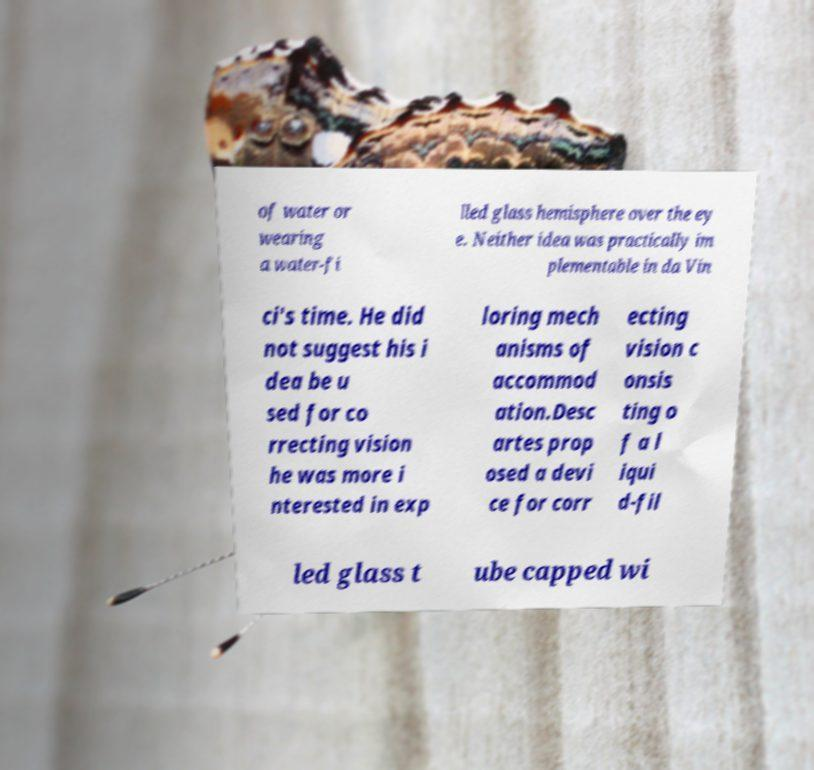Can you read and provide the text displayed in the image?This photo seems to have some interesting text. Can you extract and type it out for me? of water or wearing a water-fi lled glass hemisphere over the ey e. Neither idea was practically im plementable in da Vin ci's time. He did not suggest his i dea be u sed for co rrecting vision he was more i nterested in exp loring mech anisms of accommod ation.Desc artes prop osed a devi ce for corr ecting vision c onsis ting o f a l iqui d-fil led glass t ube capped wi 